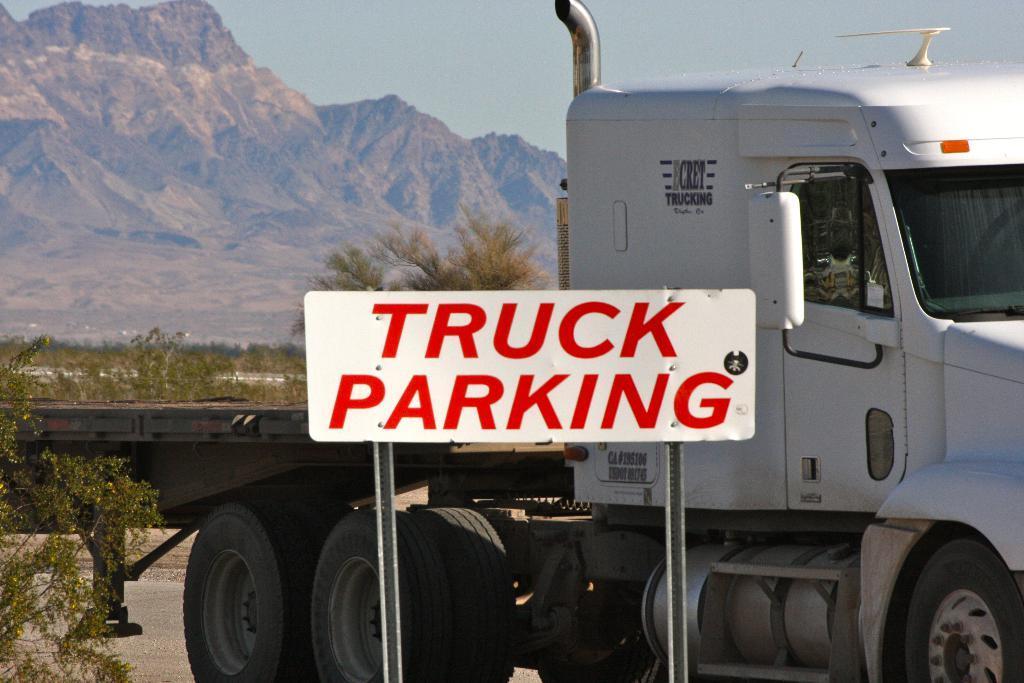Please provide a concise description of this image. This picture is clicked outside. In the center we can see the text on a white color board and we can see the metal rods and a truck and we can see the plants and trees. In the background we can see the sky and the hills. 